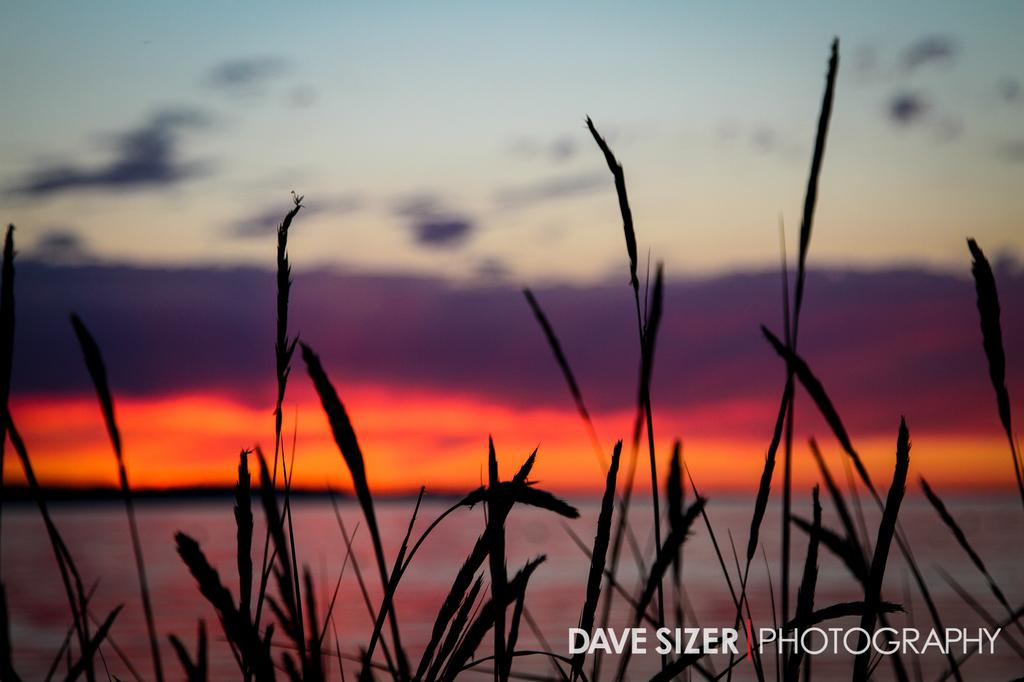What type of vegetation is present in the image? There is grass in the image. What part of the natural environment is visible in the image? The sky is visible at the top of the image. What type of sail is being used by the potato in the image? There is no potato or sail present in the image. What kind of apparatus is being used to measure the grass in the image? There is no apparatus present in the image for measuring the grass. 